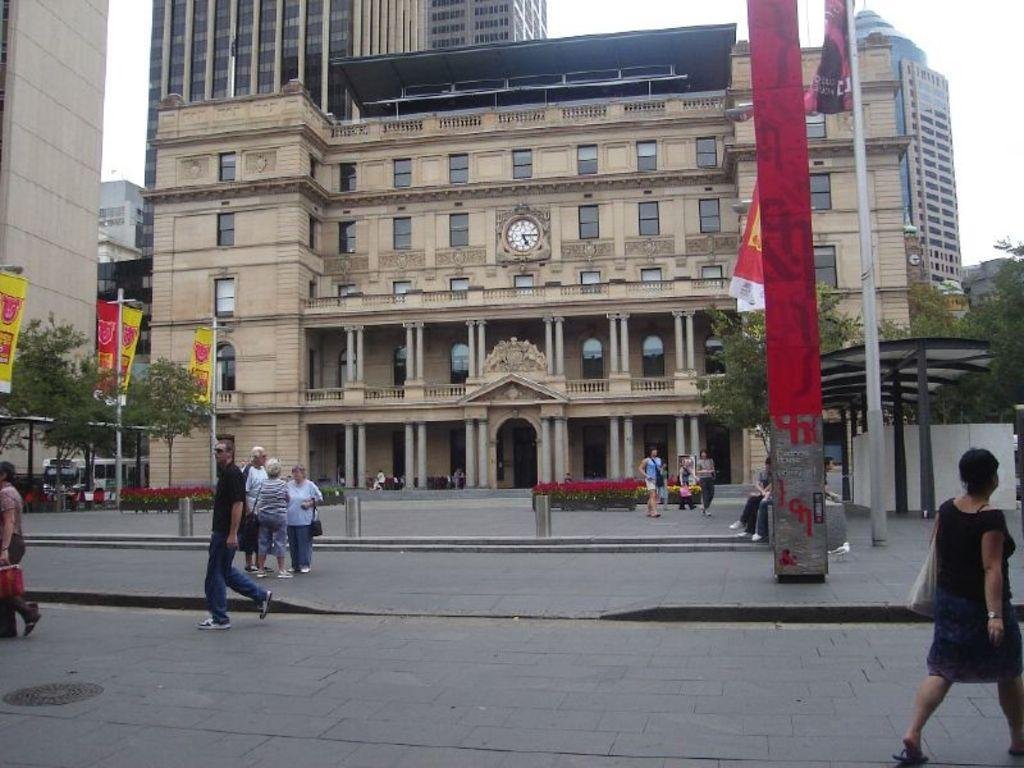How many people are present in the image? There are people in the image, but the exact number cannot be determined from the provided facts. What can be seen flying in the image? There is a flag in the image. What type of vegetation is present in the image? There are plants and trees in the image. What other decorative items can be seen in the image? There are banners in the image. What type of structures are visible in the image? There are buildings in the image. What is visible at the top of the image? The sky is visible at the top of the image. What invention is being demonstrated in the image? There is no invention being demonstrated in the image; the facts provided do not mention any such activity. Can you see a hill in the image? There is no mention of a hill in the provided facts, so it cannot be determined if one is present in the image. 